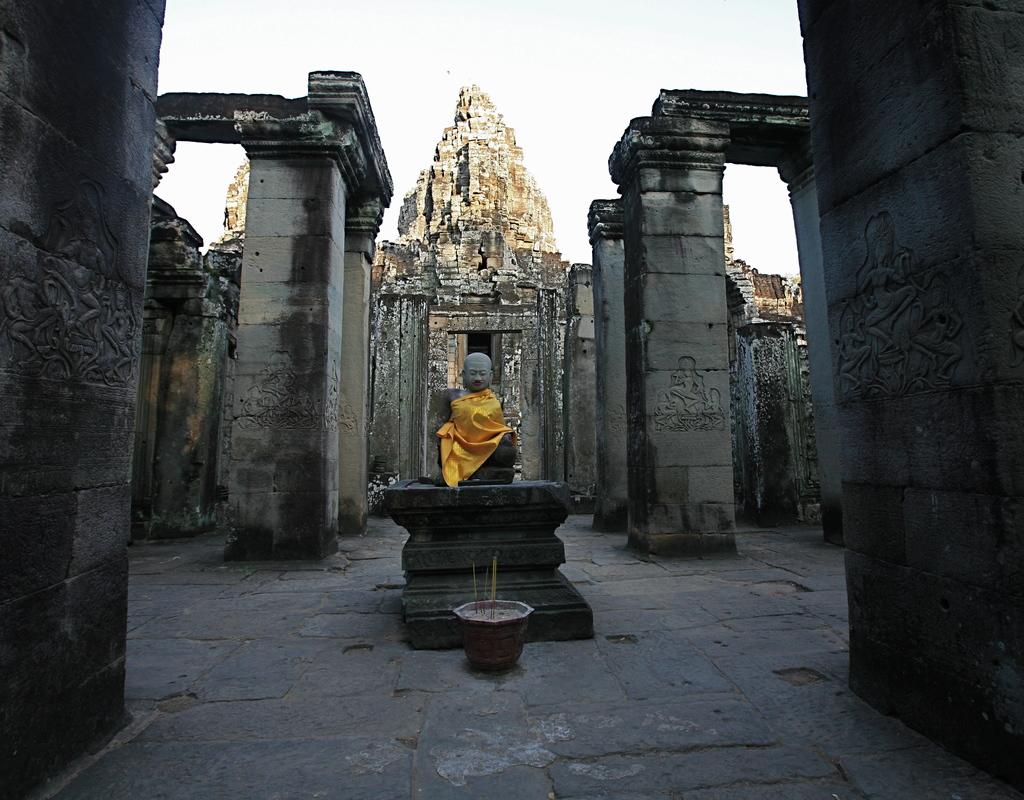What is covering the statue in the image? There is a yellow cloth on a statue in the image. What is the statue a representation of? The statue is of a person. What can be seen on the pillars in the image? There are carvings on the pillars in the image. What type of structure is visible in the image? The architecture is visible in the image. What is present on the ground in the image? There is an object on the ground in the image. What is visible in the background of the image? The sky is visible in the image. How many spiders are crawling on the statue in the image? There are no spiders visible in the image; it only shows a statue with a yellow cloth. What type of office furniture can be seen in the image? There is no office furniture present in the image. 